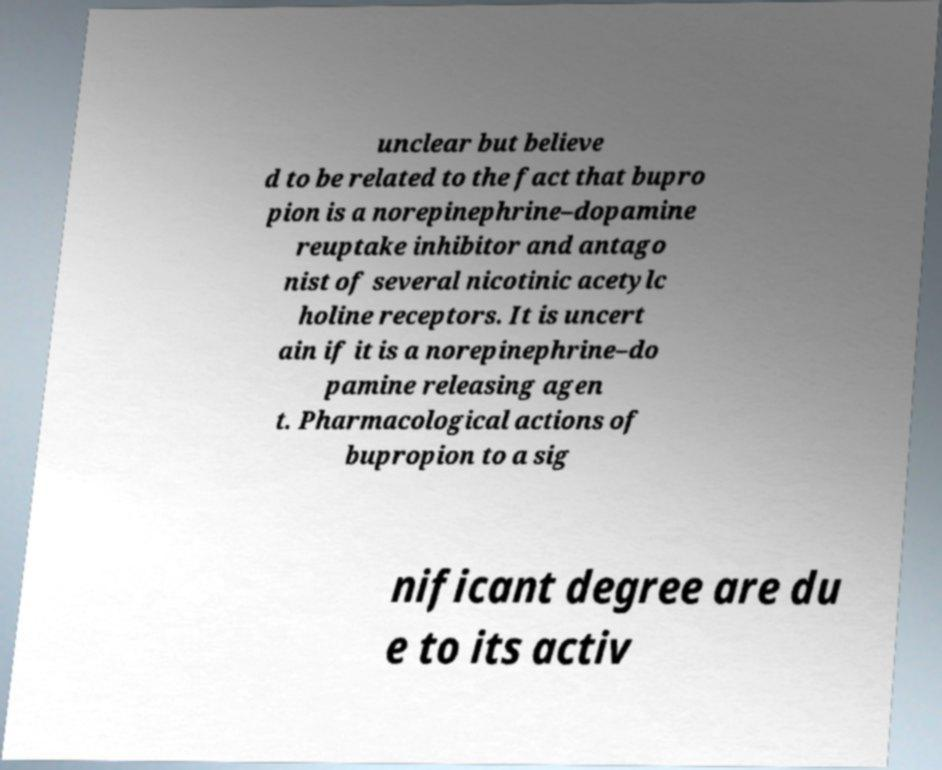Please identify and transcribe the text found in this image. unclear but believe d to be related to the fact that bupro pion is a norepinephrine–dopamine reuptake inhibitor and antago nist of several nicotinic acetylc holine receptors. It is uncert ain if it is a norepinephrine–do pamine releasing agen t. Pharmacological actions of bupropion to a sig nificant degree are du e to its activ 